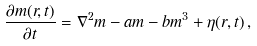Convert formula to latex. <formula><loc_0><loc_0><loc_500><loc_500>\frac { \partial m ( { r } , t ) } { \partial t } = \nabla ^ { 2 } m - a m - b m ^ { 3 } + \eta ( { r } , t ) \, ,</formula> 